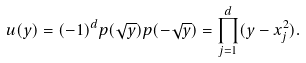<formula> <loc_0><loc_0><loc_500><loc_500>u ( y ) = ( - 1 ) ^ { d } p ( \sqrt { y } ) p ( - \sqrt { y } ) = \prod _ { j = 1 } ^ { d } ( y - x _ { j } ^ { 2 } ) .</formula> 